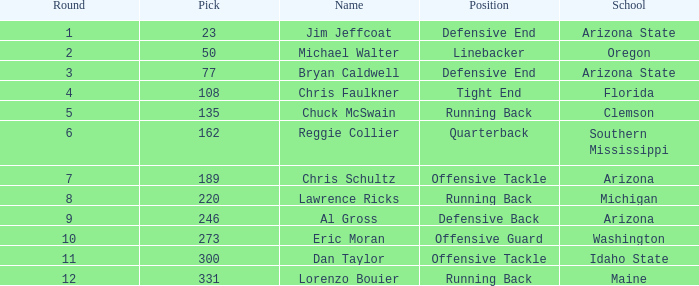What is the position of the player for Washington school? Offensive Guard. 